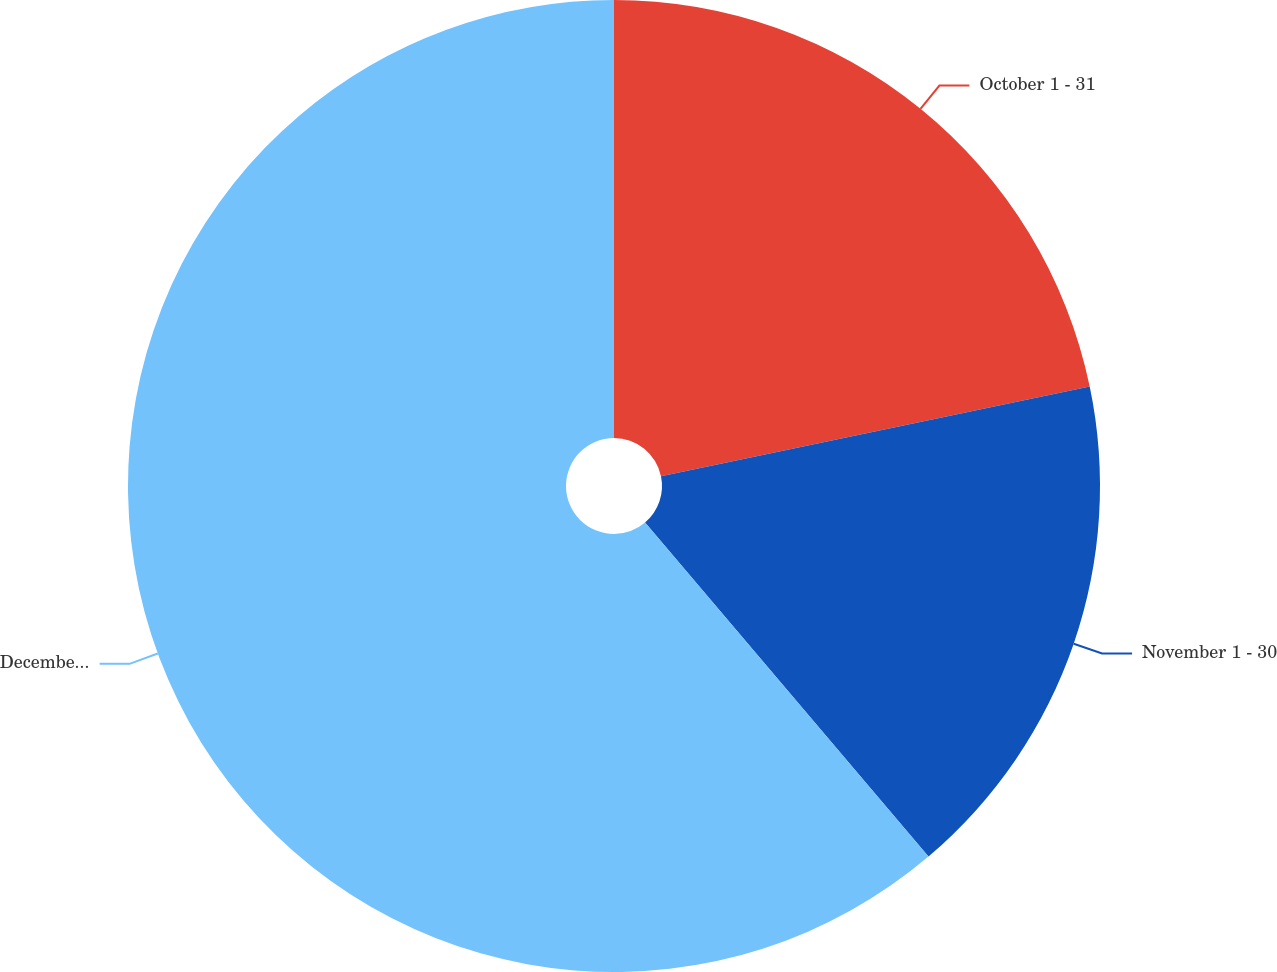Convert chart. <chart><loc_0><loc_0><loc_500><loc_500><pie_chart><fcel>October 1 - 31<fcel>November 1 - 30<fcel>December 1 - 31<nl><fcel>21.72%<fcel>17.08%<fcel>61.2%<nl></chart> 